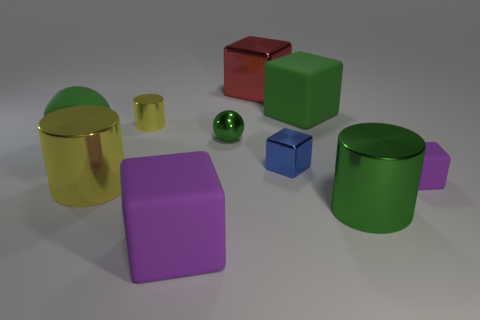Subtract all brown blocks. Subtract all gray cylinders. How many blocks are left? 5 Subtract all cylinders. How many objects are left? 7 Subtract 0 gray spheres. How many objects are left? 10 Subtract all large purple metallic cylinders. Subtract all big green cylinders. How many objects are left? 9 Add 7 green matte cubes. How many green matte cubes are left? 8 Add 2 matte cubes. How many matte cubes exist? 5 